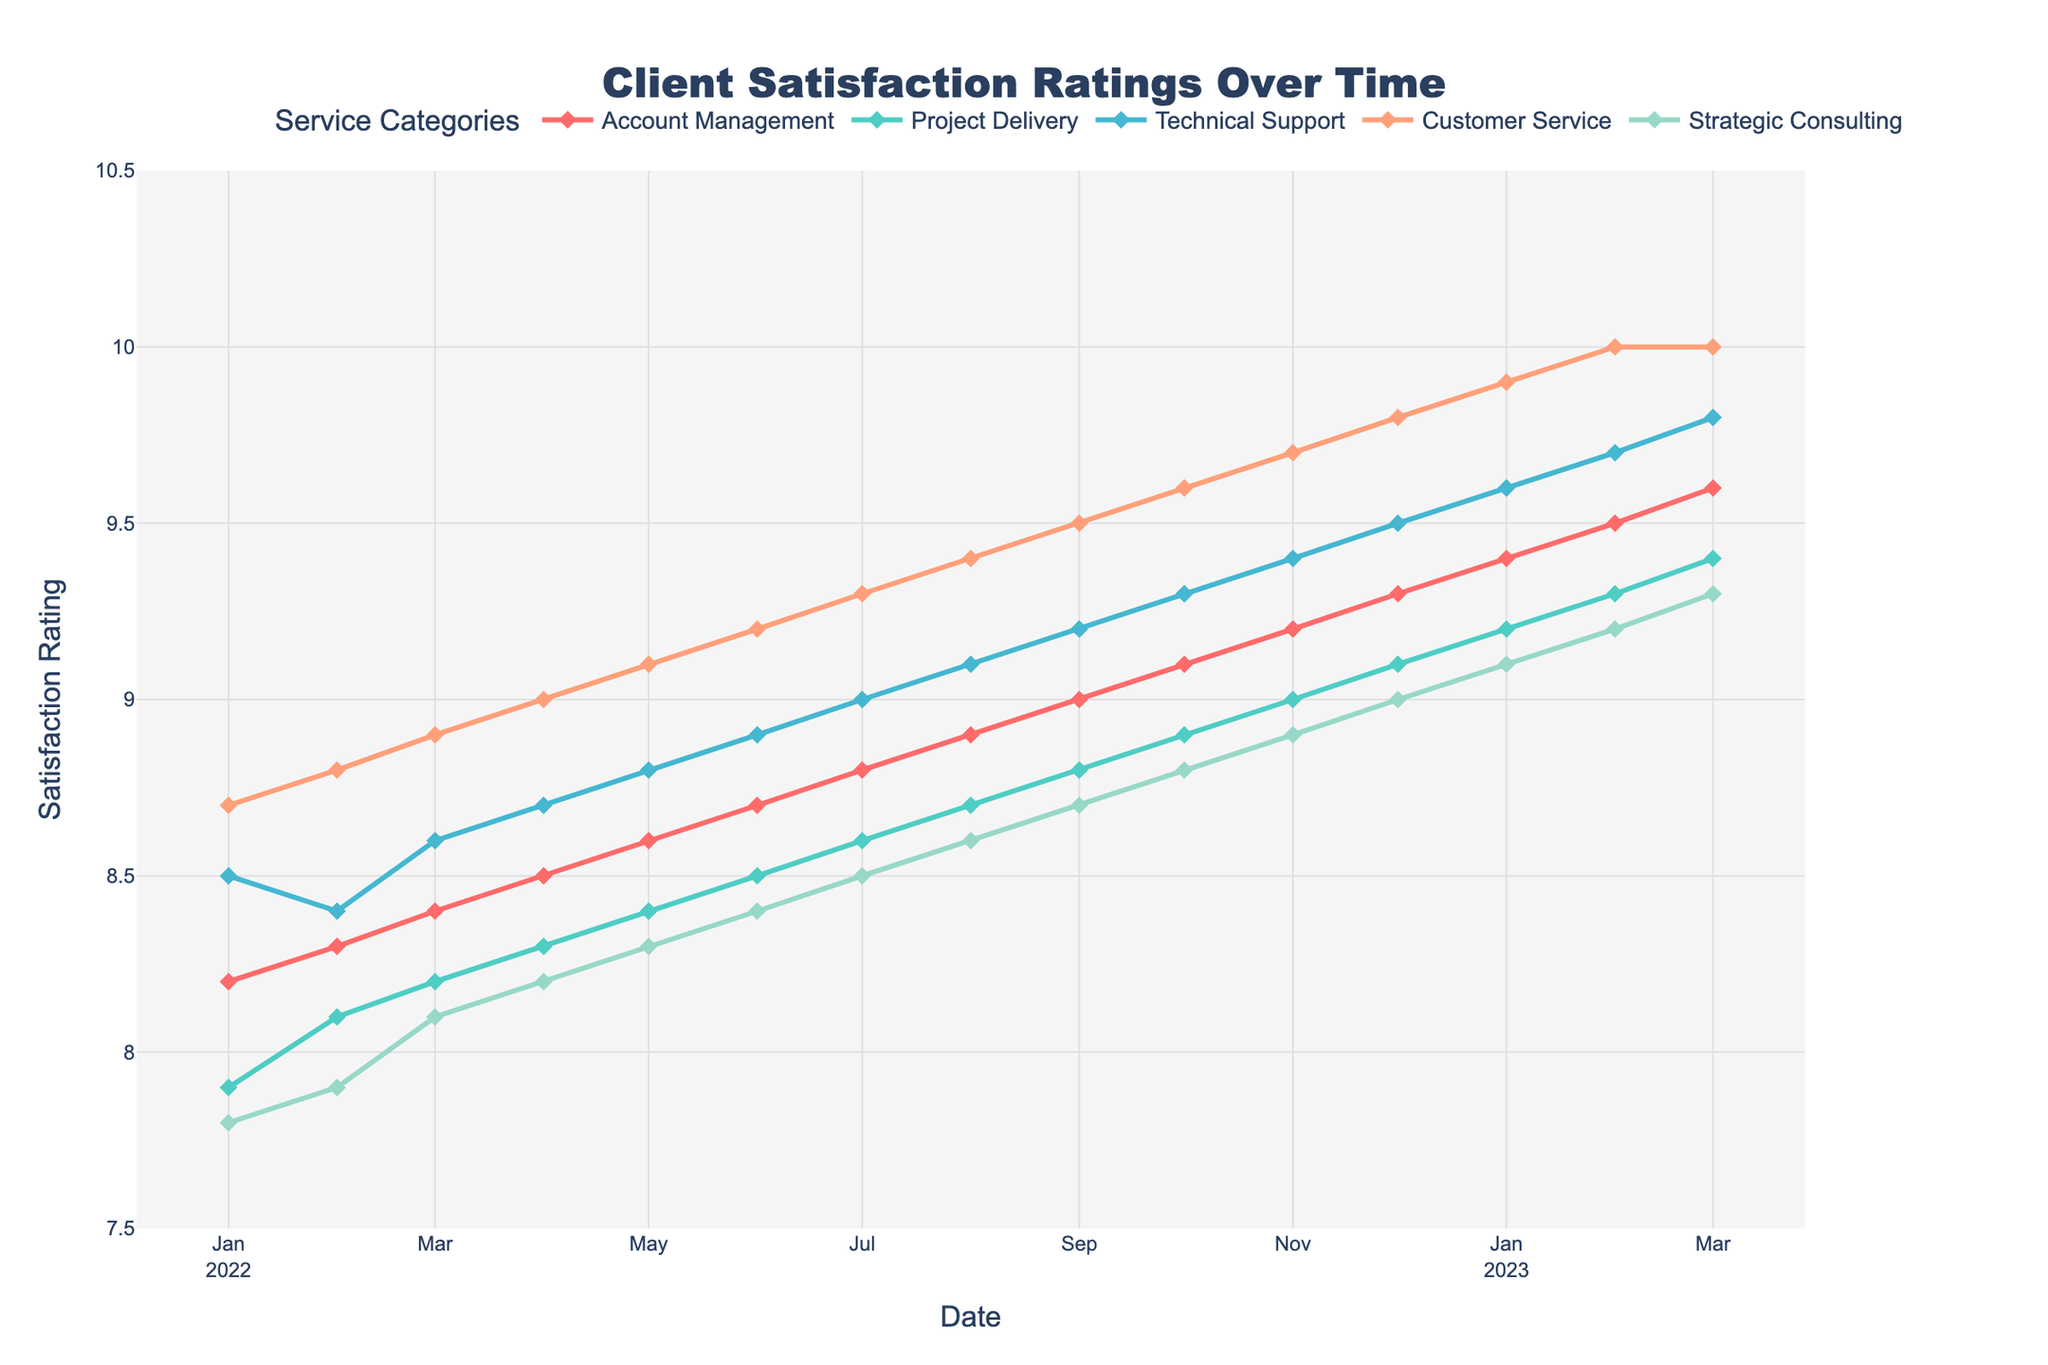Which service category had the highest client satisfaction rating in March 2022? In March 2022, the "Customer Service" category exhibited the highest satisfaction rating among all the categories. The figure shows ratings for each month, and "Customer Service" stands out with a rating of 8.9.
Answer: Customer Service Between July 2022 and December 2022, which service category had the largest increase in satisfaction ratings? Referring to the ratings between July 2022 (7th month) and December 2022 (12th month), we need to look at the difference in ratings for each service category. "Account Management" increased from 8.8 to 9.3, "Project Delivery" from 8.6 to 9.1, "Technical Support" from 9.0 to 9.5, "Customer Service" from 9.3 to 9.8, and "Strategic Consulting" from 8.5 to 9.0. The highest increase is for "Customer Service" with an increase of 0.5.
Answer: Customer Service What was the average satisfaction rating for "Technical Support" over the year 2022? For "Technical Support," sum the monthly ratings from January to December 2022: 8.5 + 8.4 + 8.6 + 8.7 + 8.8 + 8.9 + 9.0 + 9.1 + 9.2 + 9.3 + 9.4 + 9.5 = 105.4. Dividing by 12, the average rating is 105.4 / 12 ≈ 8.78.
Answer: 8.78 Which service category showed the smallest fluctuation (difference between highest and lowest ratings) over the entire period? To find the smallest fluctuation, we observe the highest and lowest ratings for each category. "Account Management" ranges from 8.2 to 9.6 (difference of 1.4), "Project Delivery" from 7.9 to 9.4 (difference of 1.5), "Technical Support" from 8.4 to 9.8 (difference of 1.4), "Customer Service" from 8.7 to 10.0 (difference of 1.3), "Strategic Consulting" from 7.8 to 9.3 (difference of 1.5). The smallest difference is for "Customer Service" at 1.3.
Answer: Customer Service In January 2023, what was the average satisfaction rating for all service categories combined? For January 2023, sum the ratings for all service categories and divide by the number of categories. Ratings are: 9.4, 9.2, 9.6, 9.9, 9.1. The sum is 9.4 + 9.2 + 9.6 + 9.9 + 9.1 = 47.2. The average is 47.2 / 5 = 9.44.
Answer: 9.44 Which month showed the highest average satisfaction rating across all service categories? Compute the average rating for each month and find the highest. For February 2023, sum the ratings (9.5, 9.3, 9.7, 10.0, 9.2) and divide by 5: (9.5 + 9.3 + 9.7 + 10.0 + 9.2) / 5 = 47.7 / 5 = 9.54, which is the highest when compared month by month.
Answer: February 2023 